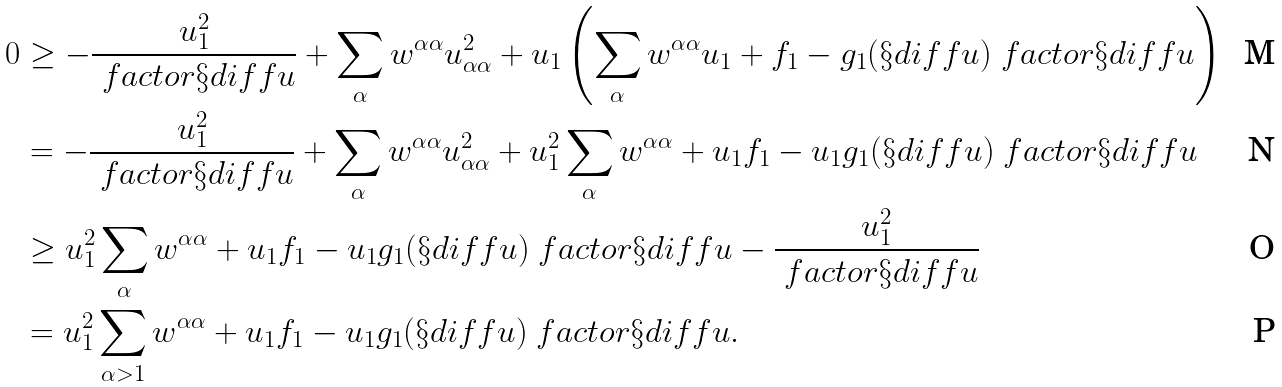<formula> <loc_0><loc_0><loc_500><loc_500>0 & \geq - \frac { u _ { 1 } ^ { 2 } } { \ f a c t o r { \S d i f f { u } } } + \sum _ { \alpha } w ^ { \alpha \alpha } u _ { \alpha \alpha } ^ { 2 } + u _ { 1 } \left ( \sum _ { \alpha } w ^ { \alpha \alpha } u _ { 1 } + f _ { 1 } - g _ { 1 } ( \S d i f f { u } ) \ f a c t o r { \S d i f f { u } } \right ) \\ & = - \frac { u _ { 1 } ^ { 2 } } { \ f a c t o r { \S d i f f { u } } } + \sum _ { \alpha } w ^ { \alpha \alpha } u _ { \alpha \alpha } ^ { 2 } + u _ { 1 } ^ { 2 } \sum _ { \alpha } w ^ { \alpha \alpha } + u _ { 1 } f _ { 1 } - u _ { 1 } g _ { 1 } ( \S d i f f { u } ) \ f a c t o r { \S d i f f { u } } \\ & \geq u _ { 1 } ^ { 2 } \sum _ { \alpha } w ^ { \alpha \alpha } + u _ { 1 } f _ { 1 } - u _ { 1 } g _ { 1 } ( \S d i f f { u } ) \ f a c t o r { \S d i f f { u } } - \frac { u _ { 1 } ^ { 2 } } { \ f a c t o r { \S d i f f { u } } } \\ & = u _ { 1 } ^ { 2 } \sum _ { \alpha > 1 } w ^ { \alpha \alpha } + u _ { 1 } f _ { 1 } - u _ { 1 } g _ { 1 } ( \S d i f f { u } ) \ f a c t o r { \S d i f f { u } } .</formula> 